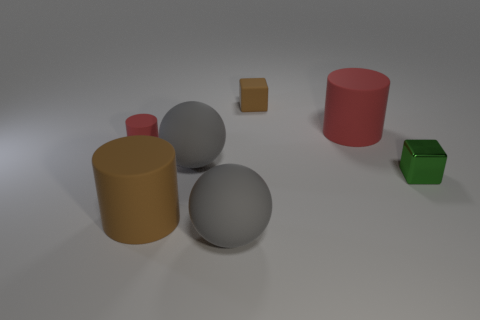Is the number of tiny metallic things right of the large red cylinder greater than the number of small metal cubes behind the shiny thing?
Ensure brevity in your answer.  Yes. The small matte thing that is the same shape as the large brown object is what color?
Offer a very short reply. Red. Is the shape of the big red thing the same as the gray thing behind the brown matte cylinder?
Ensure brevity in your answer.  No. How many other things are there of the same material as the green cube?
Your answer should be very brief. 0. Do the small matte block and the rubber cylinder to the right of the large brown thing have the same color?
Offer a very short reply. No. There is a big gray object in front of the brown cylinder; what is its material?
Keep it short and to the point. Rubber. Are there any tiny rubber objects that have the same color as the rubber block?
Your answer should be compact. No. The cylinder that is the same size as the metallic block is what color?
Offer a terse response. Red. What number of small objects are green shiny things or brown things?
Ensure brevity in your answer.  2. Is the number of green objects that are on the left side of the small brown thing the same as the number of large objects that are left of the large brown matte object?
Ensure brevity in your answer.  Yes. 